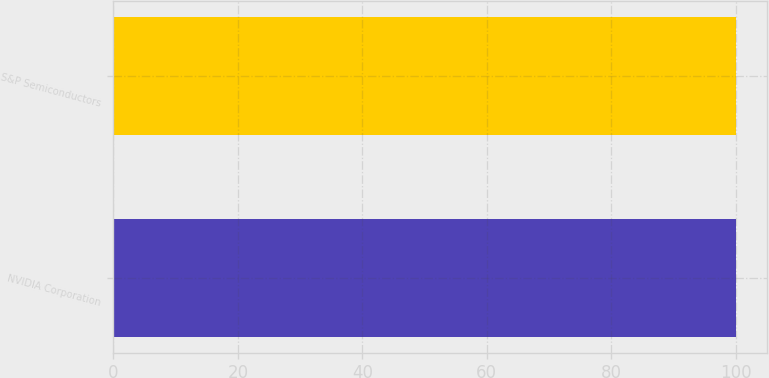<chart> <loc_0><loc_0><loc_500><loc_500><bar_chart><fcel>NVIDIA Corporation<fcel>S&P Semiconductors<nl><fcel>100<fcel>100.1<nl></chart> 